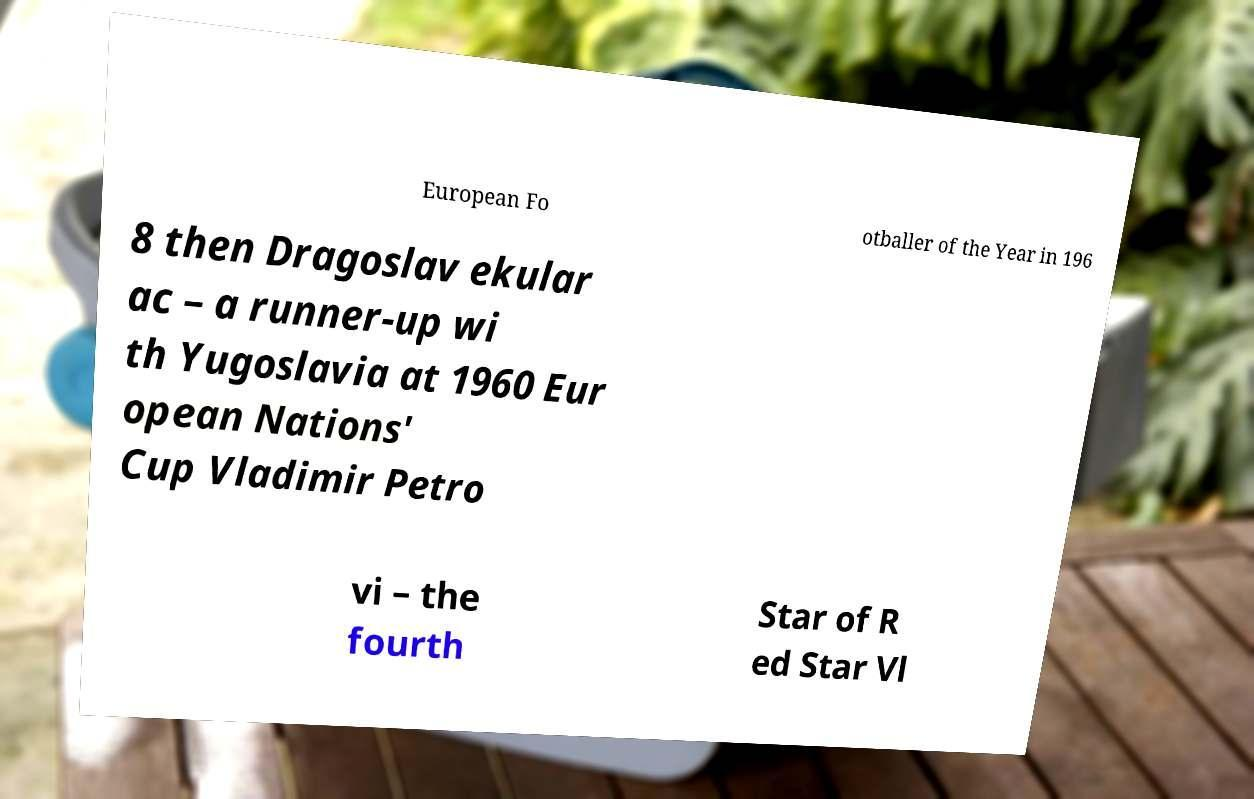For documentation purposes, I need the text within this image transcribed. Could you provide that? European Fo otballer of the Year in 196 8 then Dragoslav ekular ac – a runner-up wi th Yugoslavia at 1960 Eur opean Nations' Cup Vladimir Petro vi – the fourth Star of R ed Star Vl 